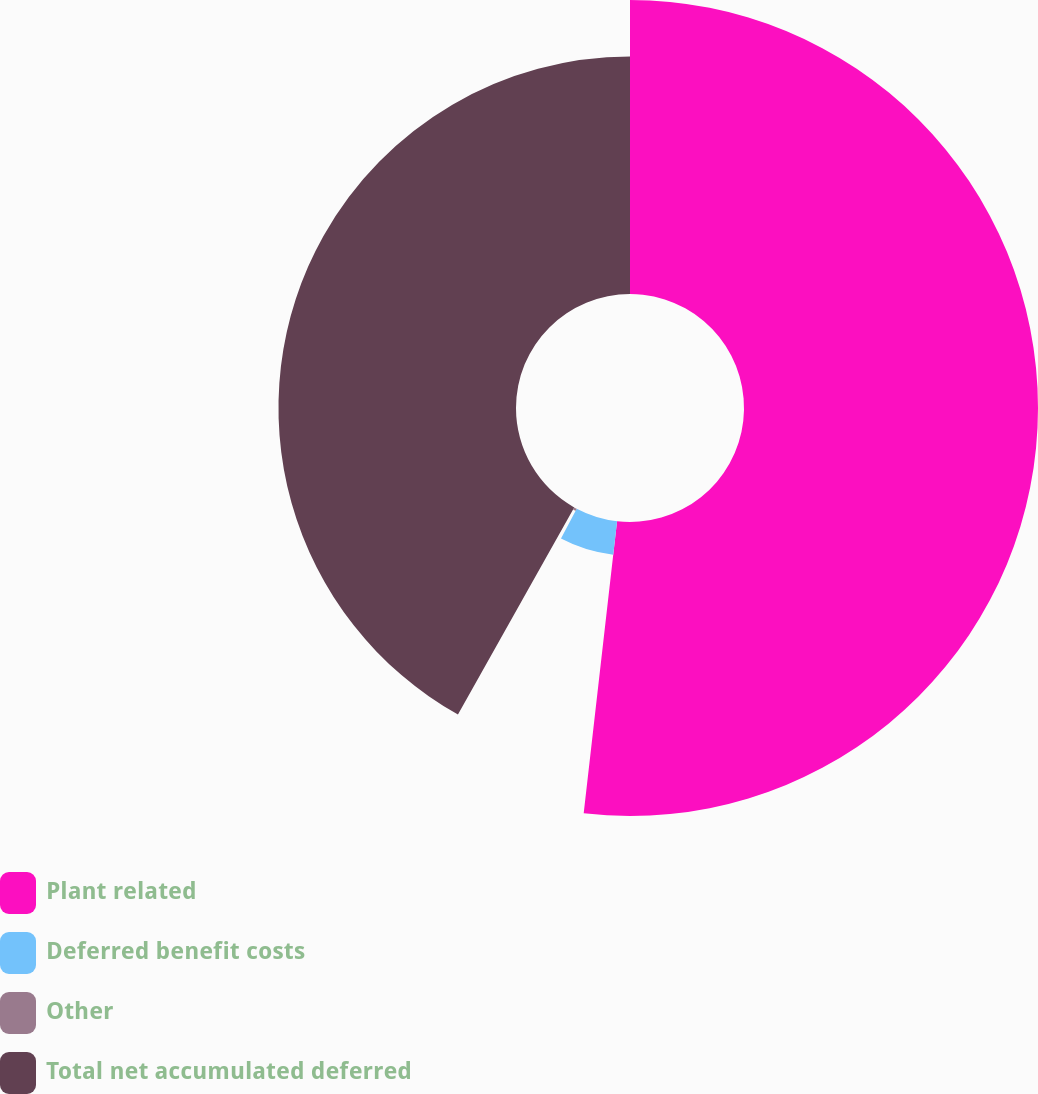Convert chart. <chart><loc_0><loc_0><loc_500><loc_500><pie_chart><fcel>Plant related<fcel>Deferred benefit costs<fcel>Other<fcel>Total net accumulated deferred<nl><fcel>51.81%<fcel>5.93%<fcel>0.4%<fcel>41.86%<nl></chart> 